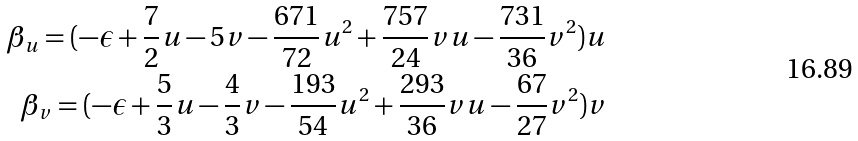Convert formula to latex. <formula><loc_0><loc_0><loc_500><loc_500>\beta _ { u } = ( - \epsilon + \frac { 7 } { 2 } u - 5 v - \frac { 6 7 1 } { 7 2 } u ^ { 2 } + \frac { 7 5 7 } { 2 4 } v u - \frac { 7 3 1 } { 3 6 } v ^ { 2 } ) u \\ \beta _ { v } = ( - \epsilon + \frac { 5 } { 3 } u - \frac { 4 } { 3 } v - \frac { 1 9 3 } { 5 4 } u ^ { 2 } + \frac { 2 9 3 } { 3 6 } v u - \frac { 6 7 } { 2 7 } v ^ { 2 } ) v</formula> 